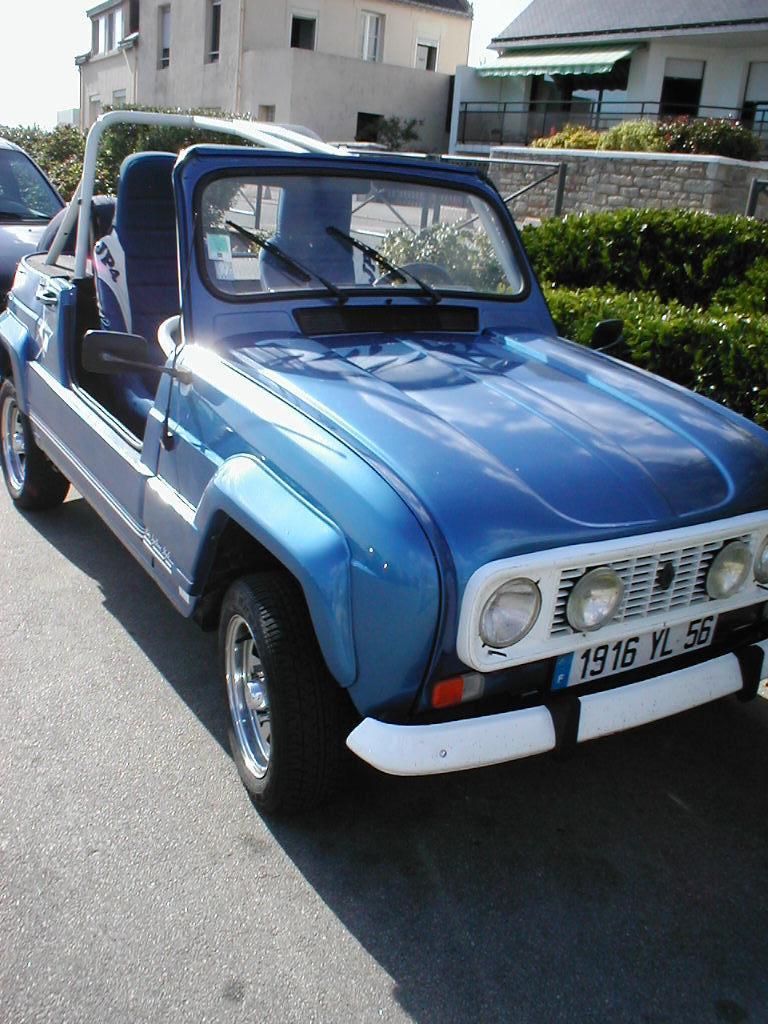Describe this image in one or two sentences. In this image, in the middle, we can see a car which is in blue color. On the right side, we can see some plants, house, door. On the left side, we can also see a car, trees, plants, building, window. At the top, we can see a sky, at the bottom, we can see a road. 